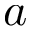<formula> <loc_0><loc_0><loc_500><loc_500>a</formula> 